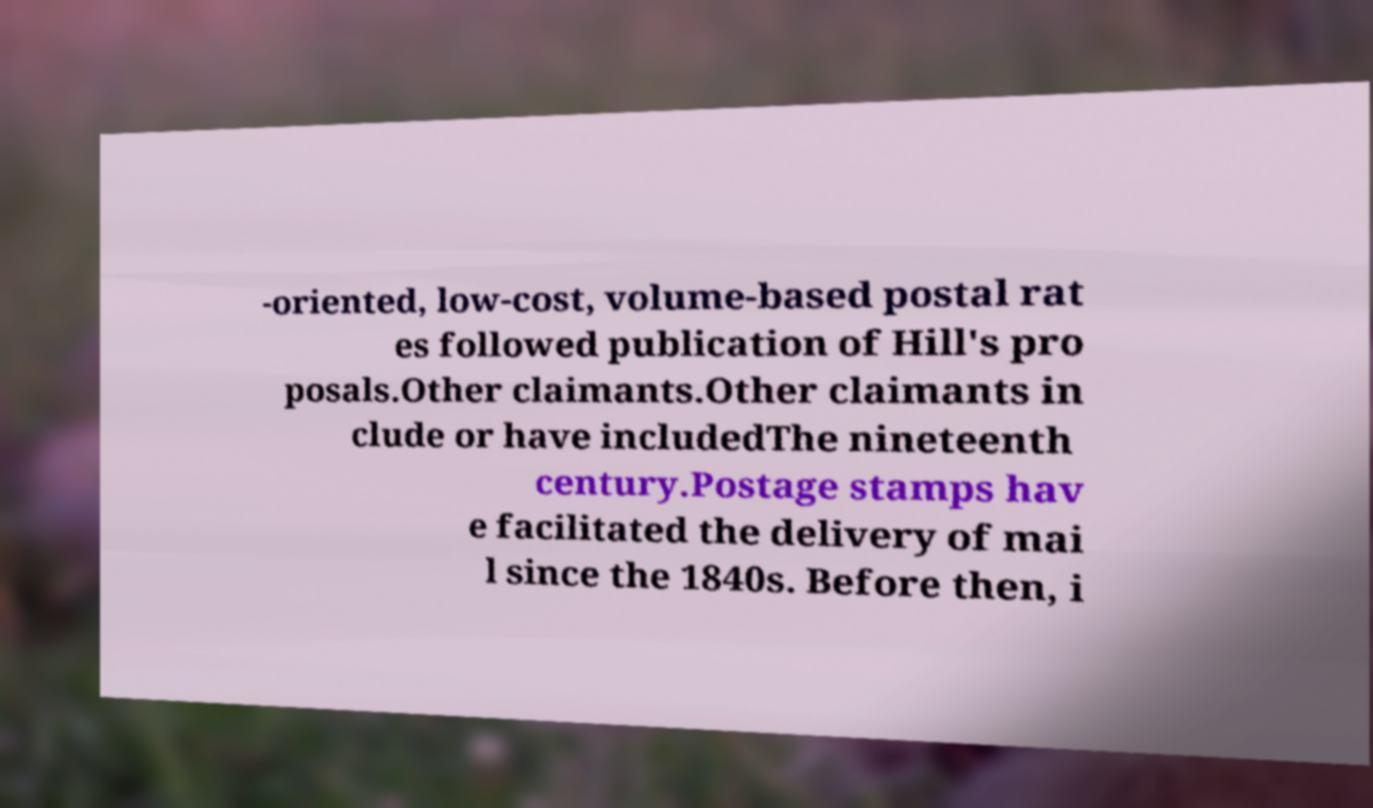For documentation purposes, I need the text within this image transcribed. Could you provide that? -oriented, low-cost, volume-based postal rat es followed publication of Hill's pro posals.Other claimants.Other claimants in clude or have includedThe nineteenth century.Postage stamps hav e facilitated the delivery of mai l since the 1840s. Before then, i 